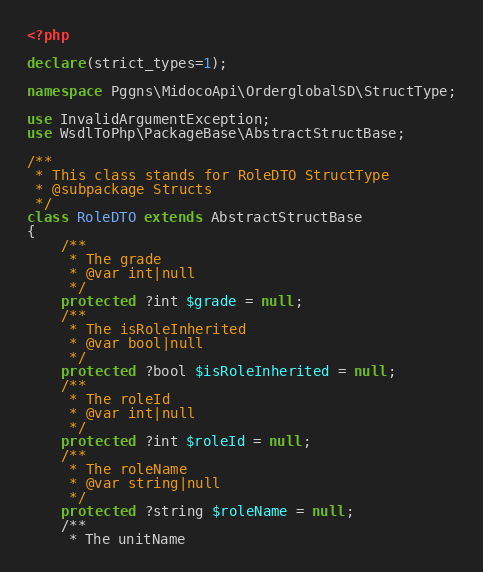Convert code to text. <code><loc_0><loc_0><loc_500><loc_500><_PHP_><?php

declare(strict_types=1);

namespace Pggns\MidocoApi\OrderglobalSD\StructType;

use InvalidArgumentException;
use WsdlToPhp\PackageBase\AbstractStructBase;

/**
 * This class stands for RoleDTO StructType
 * @subpackage Structs
 */
class RoleDTO extends AbstractStructBase
{
    /**
     * The grade
     * @var int|null
     */
    protected ?int $grade = null;
    /**
     * The isRoleInherited
     * @var bool|null
     */
    protected ?bool $isRoleInherited = null;
    /**
     * The roleId
     * @var int|null
     */
    protected ?int $roleId = null;
    /**
     * The roleName
     * @var string|null
     */
    protected ?string $roleName = null;
    /**
     * The unitName</code> 